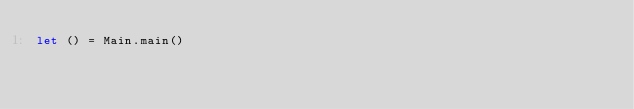Convert code to text. <code><loc_0><loc_0><loc_500><loc_500><_OCaml_>let () = Main.main()
</code> 